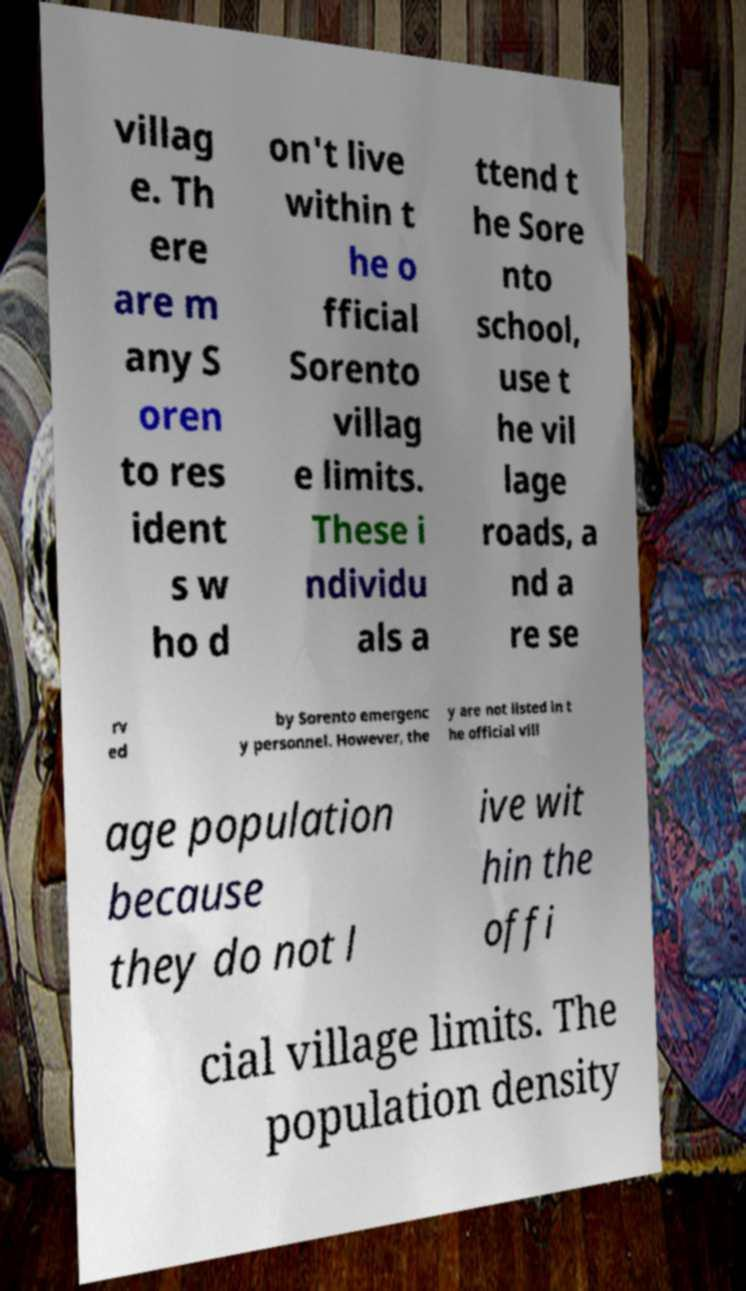Could you assist in decoding the text presented in this image and type it out clearly? villag e. Th ere are m any S oren to res ident s w ho d on't live within t he o fficial Sorento villag e limits. These i ndividu als a ttend t he Sore nto school, use t he vil lage roads, a nd a re se rv ed by Sorento emergenc y personnel. However, the y are not listed in t he official vill age population because they do not l ive wit hin the offi cial village limits. The population density 